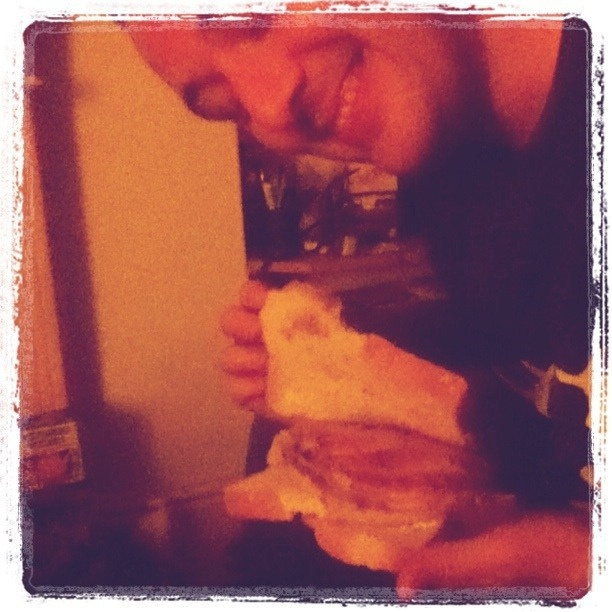Describe the objects in this image and their specific colors. I can see people in white, purple, red, and brown tones and sandwich in white, red, brown, orange, and purple tones in this image. 